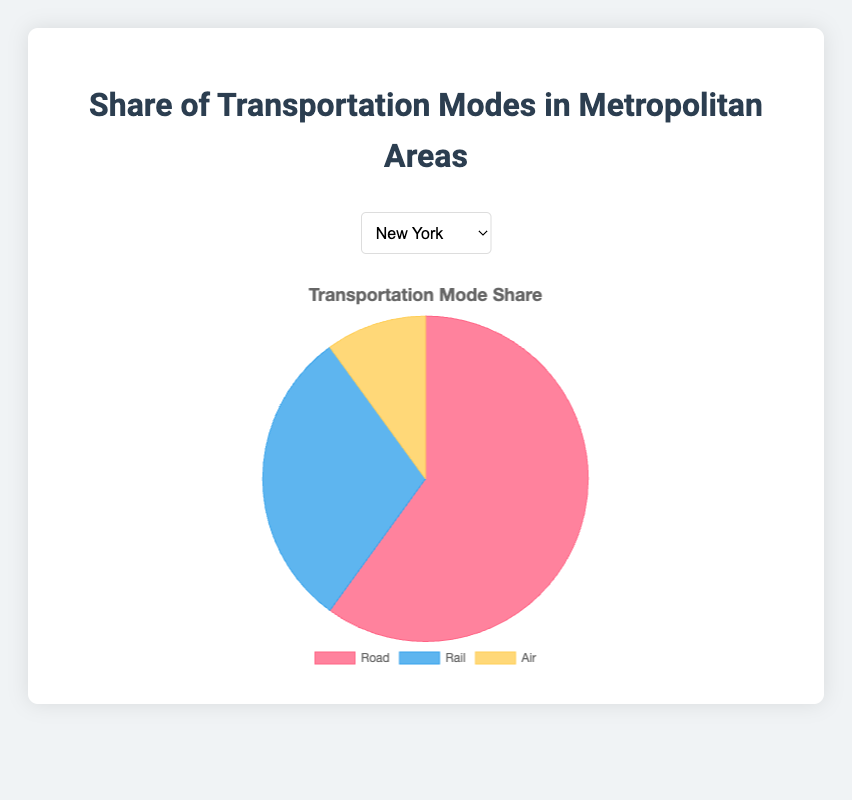Which city has the highest share of road transport? To determine which city has the highest share of road transport, look at the road transport percentages for all cities. Los Angeles has the highest with 70%.
Answer: Los Angeles Which city has the lowest share of air transport? To find the city with the lowest share of air transport, look at the air transport percentages for all cities. Both Tokyo and Paris have the lowest with 5%.
Answer: Tokyo and Paris What is the combined share of road and rail transport in London? To find the combined share, add the road transport (50%) and rail transport (40%) percentages for London. 50% + 40% = 90%.
Answer: 90% Which transportation mode has the smallest share in Tokyo? Refer to the transportation mode shares in Tokyo. The air transport has the smallest share with 5%.
Answer: Air transport Compare the share of rail transport between New York and Chicago, which one is greater? By comparing the rail transport percentages, New York has 30% and Chicago has 35%. So, Chicago has the greater share.
Answer: Chicago What is the difference in the share of road transport between Los Angeles and Tokyo? Subtract Tokyo's road transport share (45%) from Los Angeles's road transport share (70%). 70% - 45% = 25%.
Answer: 25% How much more share does road transport have than air transport in New York? Subtract the air transport share (10%) from the road transport share (60%) in New York. 60% - 10% = 50%.
Answer: 50% Which transportation mode has the largest visual representation in the pie chart for New York? Look at the largest segment in the pie chart for New York. The road transport segment is the largest.
Answer: Road transport What is the average share of rail transport across all cities? Add all the rail transport shares: 30% (New York) + 20% (Los Angeles) + 35% (Chicago) + 40% (London) + 50% (Tokyo) + 30% (Paris) = 205%. Divide by the number of cities (6). 205% / 6 ≈ 34.17%.
Answer: 34.17% Which city has equal shares of air transport visually represented as yellow? Look for the yellow segment (air transport) and find the cities with the share of 10%. New York, Los Angeles, Chicago, and London all have an equal air transport share of 10%.
Answer: New York, Los Angeles, Chicago, and London 